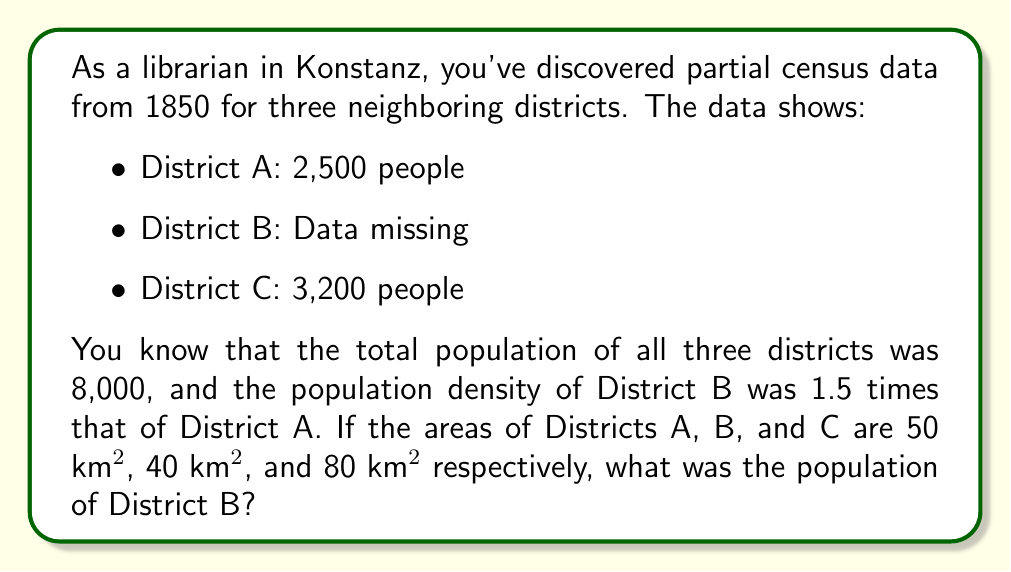Can you solve this math problem? Let's approach this step-by-step:

1) First, let's define variables:
   $x$ = population of District B
   $d_A$, $d_B$, $d_C$ = population densities of Districts A, B, and C

2) We know the total population is 8,000:
   $2500 + x + 3200 = 8000$

3) Population density is calculated as population divided by area:
   $d_A = \frac{2500}{50} = 50$ people/km²
   $d_C = \frac{3200}{80} = 40$ people/km²
   $d_B = \frac{x}{40}$

4) We're told that $d_B = 1.5d_A$:
   $\frac{x}{40} = 1.5 \cdot 50$
   $\frac{x}{40} = 75$

5) Solve for $x$:
   $x = 75 \cdot 40 = 3000$

6) Verify with the total population equation:
   $2500 + 3000 + 3200 = 8000$

Therefore, the population of District B was 3,000 people.
Answer: 3,000 people 